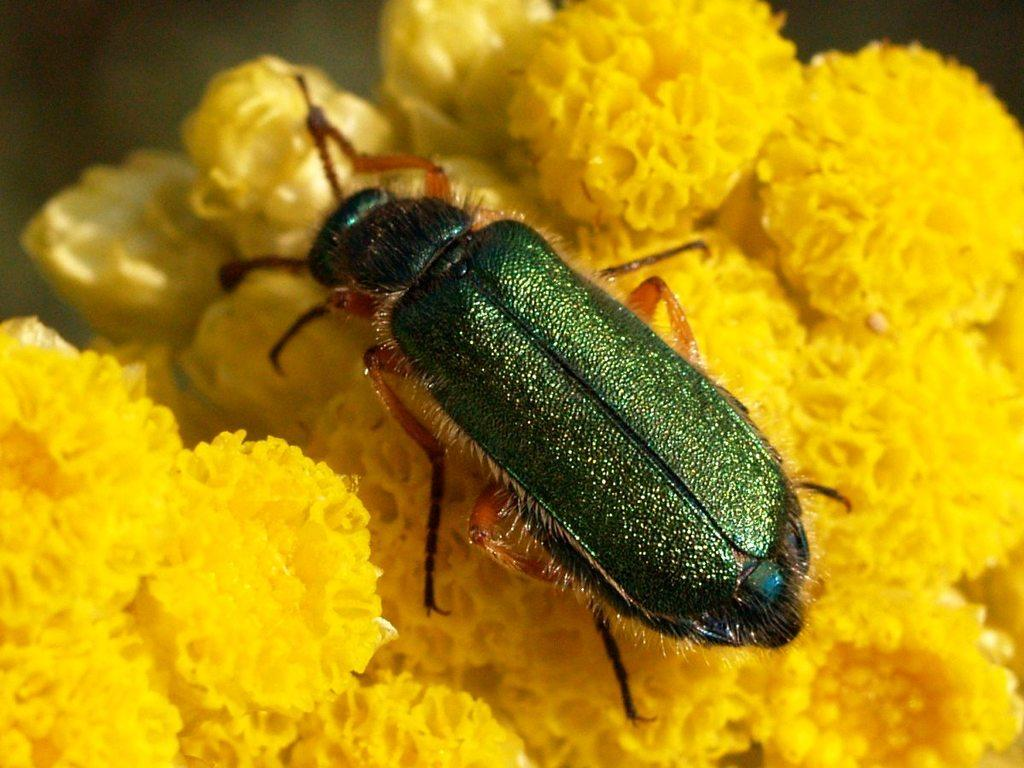What is present on the bunch of flowers in the image? There is an insect on the bunch of flowers in the image. Can you describe the insect's location on the flowers? The insect is on a bunch of flowers. What type of gold jewelry is the insect wearing in the image? There is no gold jewelry present on the insect in the image. 